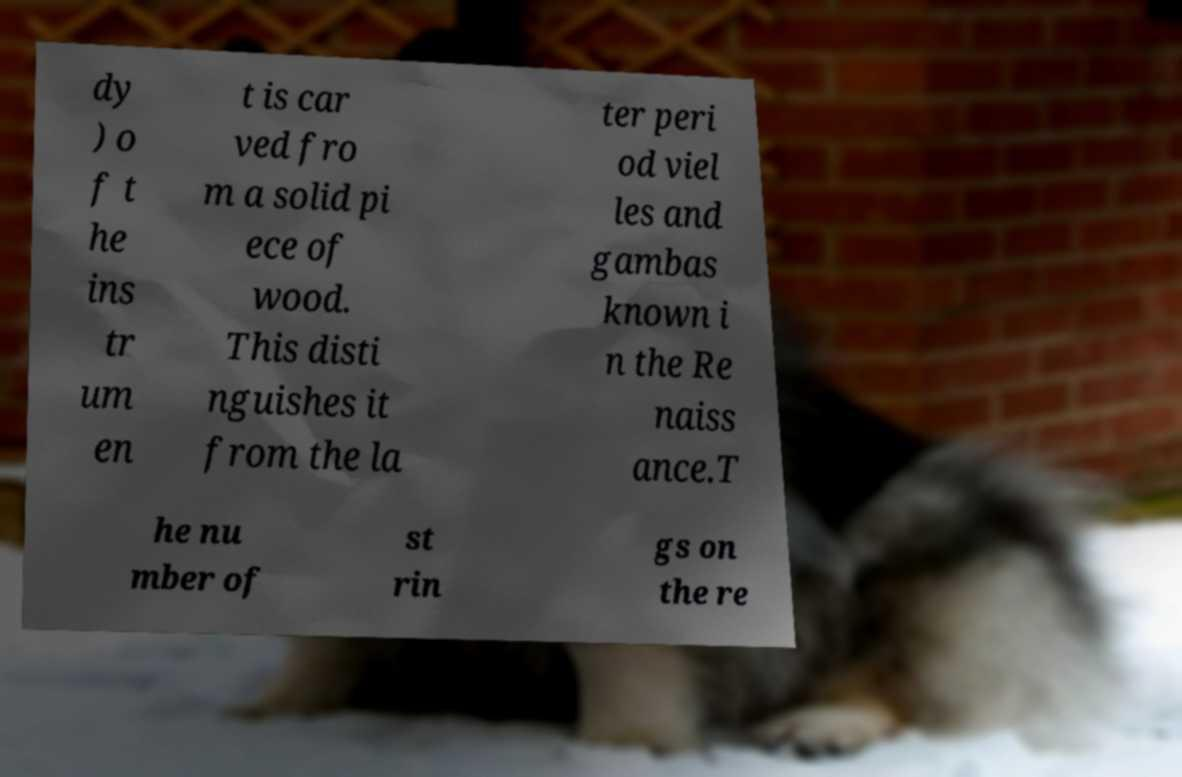Could you extract and type out the text from this image? dy ) o f t he ins tr um en t is car ved fro m a solid pi ece of wood. This disti nguishes it from the la ter peri od viel les and gambas known i n the Re naiss ance.T he nu mber of st rin gs on the re 